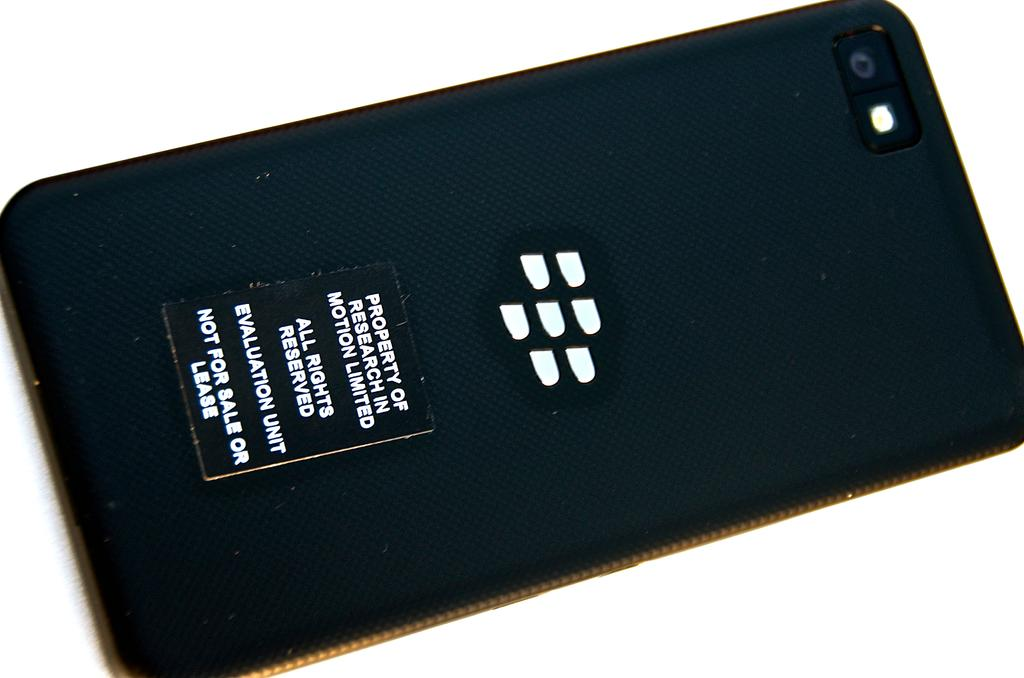Provide a one-sentence caption for the provided image. The back of a cellphone stating property of research in motion and all rights reserved. 